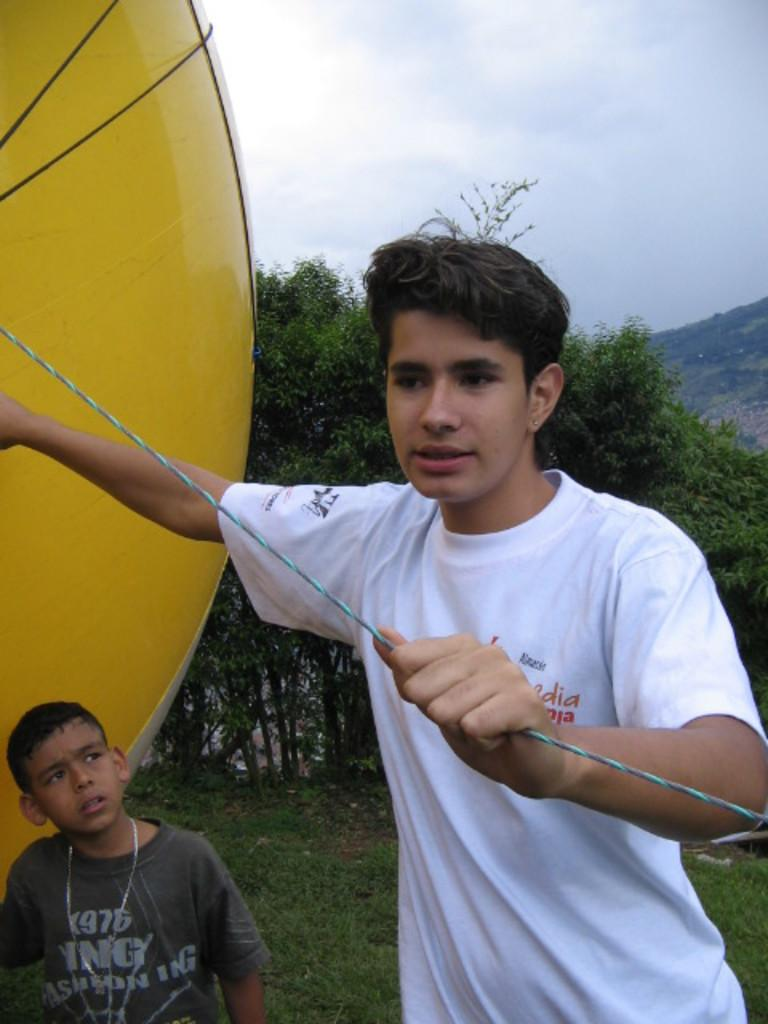What is the person in the foreground of the image holding? The person is holding a rope in the image. Can you describe the clothing of the person holding the rope? The person is wearing a white shirt. What can be seen in the background of the image? There is another person, a yellow color object, trees, a mountain, and the sky visible in the background. What colors can be seen in the sky in the image? The sky in the image has a white and blue color. What idea does the boy have while standing near the flame in the image? There is no boy or flame present in the image, so it is not possible to answer that question. 